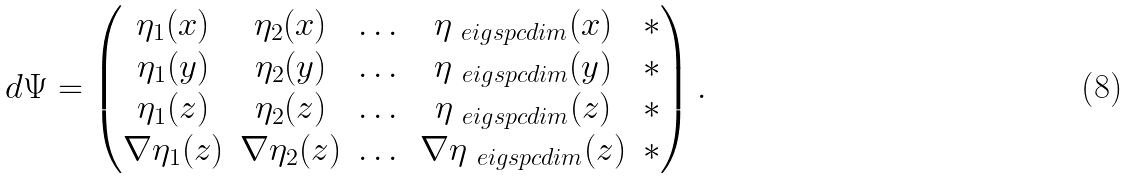Convert formula to latex. <formula><loc_0><loc_0><loc_500><loc_500>d \Psi = \left ( \begin{matrix} \eta _ { 1 } ( x ) & \eta _ { 2 } ( x ) & \dots & \eta _ { \ e i g s p c d i m } ( x ) & * \\ \eta _ { 1 } ( y ) & \eta _ { 2 } ( y ) & \dots & \eta _ { \ e i g s p c d i m } ( y ) & * \\ \eta _ { 1 } ( z ) & \eta _ { 2 } ( z ) & \dots & \eta _ { \ e i g s p c d i m } ( z ) & * \\ \nabla \eta _ { 1 } ( z ) & \nabla \eta _ { 2 } ( z ) & \dots & \nabla \eta _ { \ e i g s p c d i m } ( z ) & * \end{matrix} \right ) .</formula> 